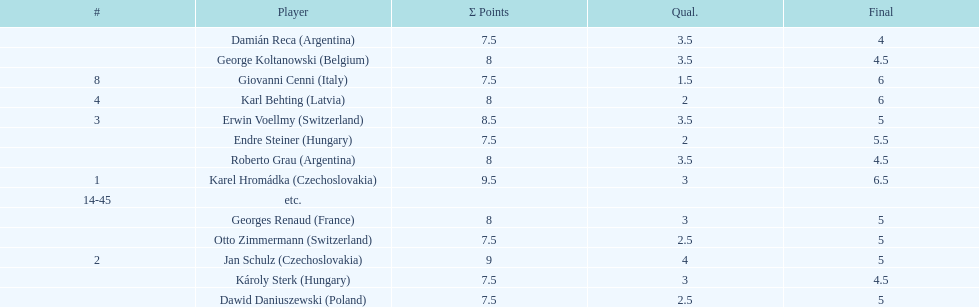Who was the top scorer from switzerland? Erwin Voellmy. 